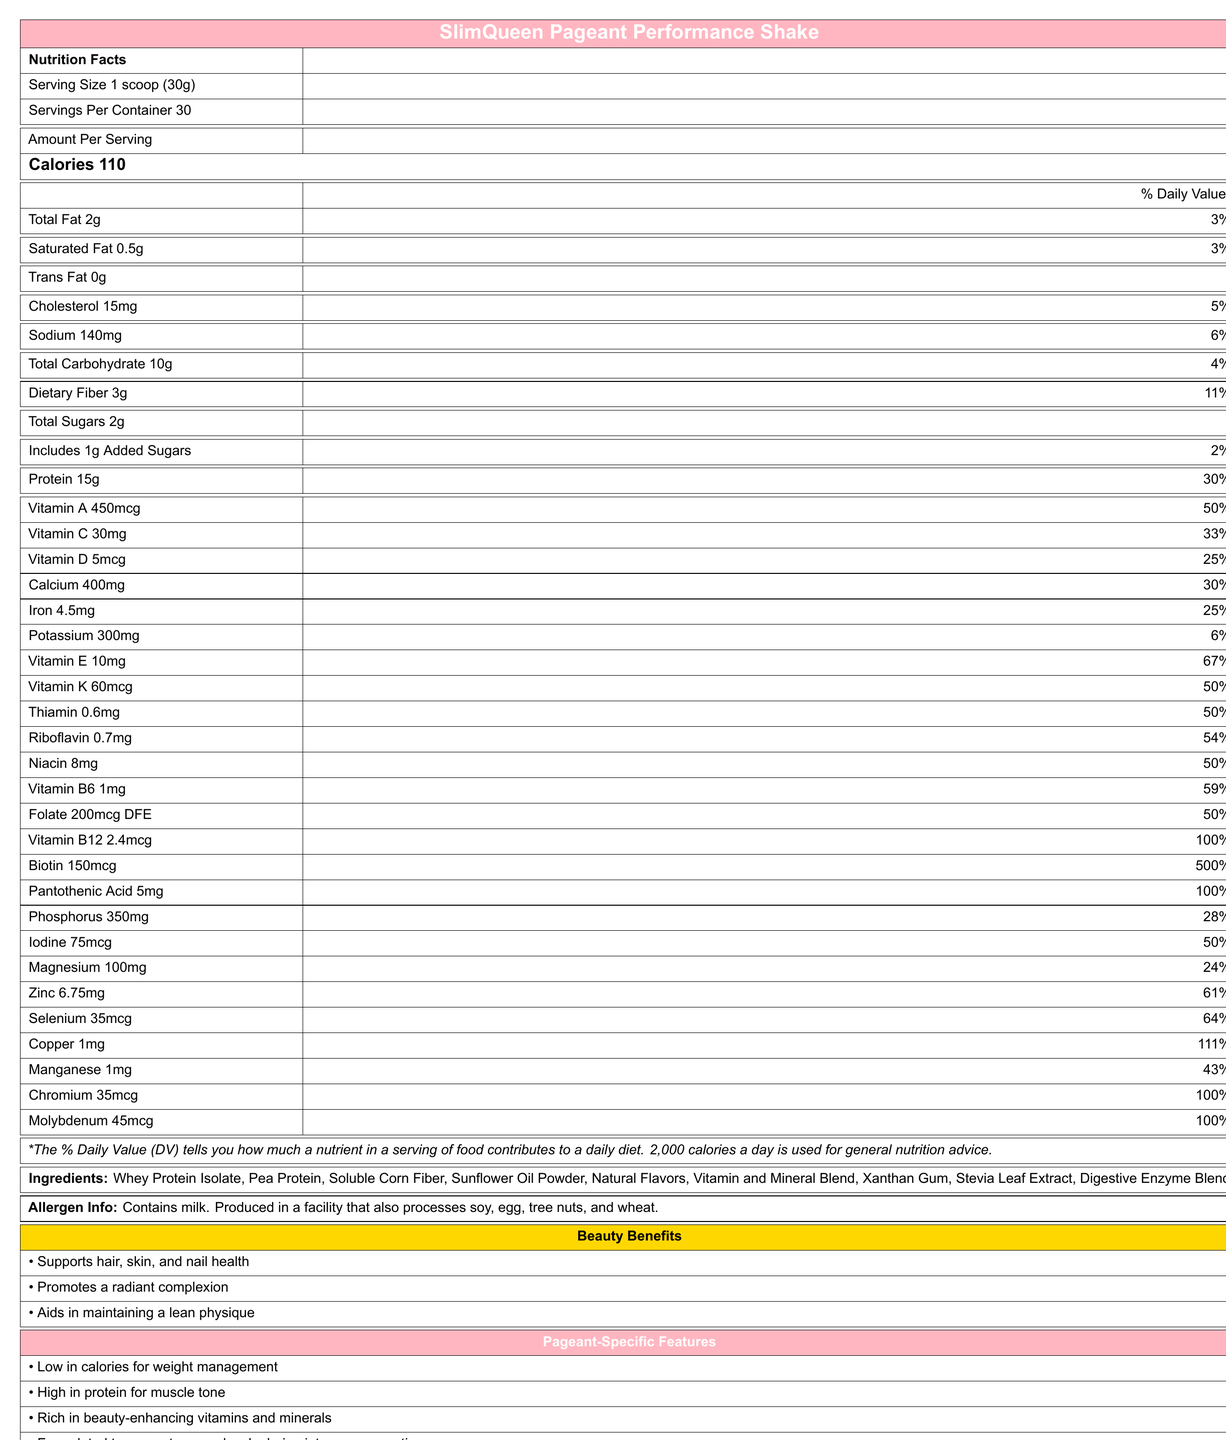what is the serving size of SlimQueen Pageant Performance Shake? The serving size is mentioned directly under the product name in the Nutrition Facts section.
Answer: 1 scoop (30g) how many calories are in one serving? The number of calories per serving is stated explicitly in the Amount Per Serving area.
Answer: 110 what percentage of the daily value of Vitamin B12 does one serving provide? The document lists the daily value of Vitamin B12 as 100% per serving.
Answer: 100% how much protein is in one serving? The amount of protein per serving is listed as 15g in the Amount Per Serving section.
Answer: 15g what is the total fat content per serving? The total fat per serving is given as 2g in the Amount Per Serving section.
Answer: 2g which of the following ingredients is NOT included in the SlimQueen Pageant Performance Shake? A. Whey Protein Isolate B. Soy Protein C. Sunflower Oil Powder The list of ingredients includes Whey Protein Isolate and Sunflower Oil Powder but does not mention Soy Protein.
Answer: B which attribute is NOT mentioned among the Pageant-Specific Features? 1. Low in calories for weight management 2. High in protein for muscle tone 3. Enhances muscle recovery 4. Formulated to support energy levels during intense preparation The document lists the first, second, and fourth attributes but does not mention enhancing muscle recovery as a Pageant-Specific Feature.
Answer: 3 is the SlimQueen Pageant Performance Shake gluten-free? The allergen information states it is produced in a facility that processes wheat, but it does not explicitly state whether the product itself is gluten-free.
Answer: Not enough information is there any trans fat in one serving of the shake? The document explicitly states that the trans fat content is 0g.
Answer: No does one serving of the shake provide more than 50% of the daily value of Vitamin A? The document states that one serving provides 50% of the daily value for Vitamin A.
Answer: Yes summarize the main idea of the document. The document primarily details the nutritional breakdown and benefits of the SlimQueen Pageant Performance Shake, emphasizing its relevance for beauty and pageant contestants and listing essential nutritional information, ingredients, and specific features beneficial for pageants.
Answer: The document provides detailed nutritional information for the SlimQueen Pageant Performance Shake, including serving size, calories, macronutrients, vitamins, and minerals. It highlights the product's benefits for beauty and pageant contestants, lists the ingredients and potential allergens, and specifies its advantages for pageant performance like low calories and high protein content. how many servings are there in one container of the shake? The document specifies that there are 30 servings per container.
Answer: 30 what is one beauty benefit mentioned for the shake? One of the beauty benefits listed is that it supports hair, skin, and nail health.
Answer: Supports hair, skin, and nail health how much dietary fiber is in one serving? The nutritional information lists the dietary fiber content as 3g per serving.
Answer: 3g why might a contestant choose this shake for energy levels? The Pageant-Specific Features section states that the shake is formulated to support energy levels during intense preparation.
Answer: It is formulated to support energy levels during intense preparation. 